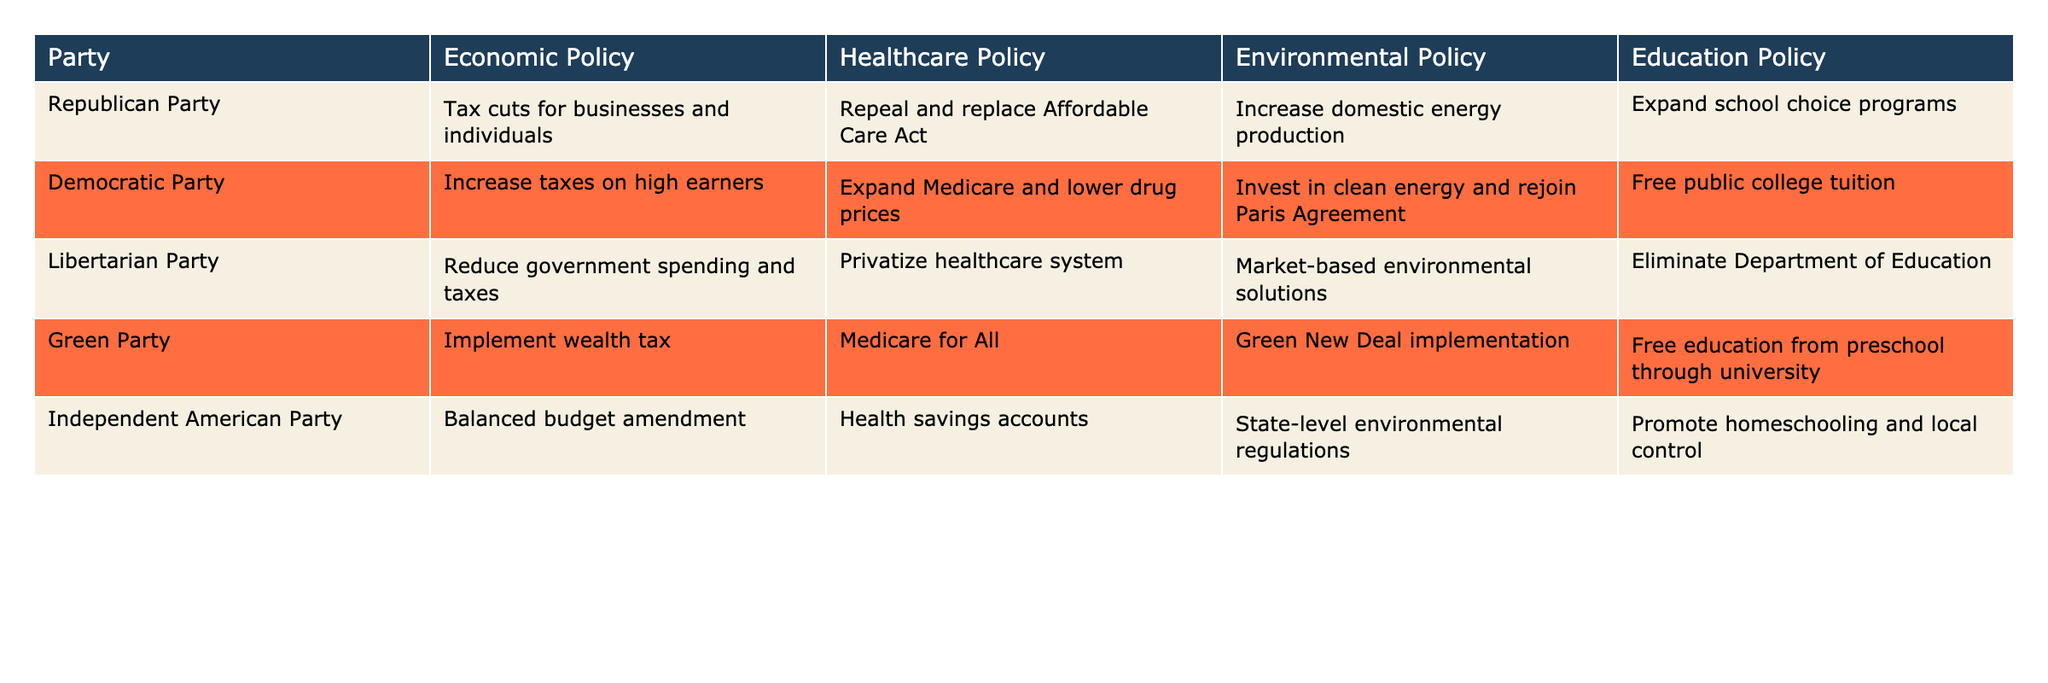What economic policy does the Green Party propose? The Green Party's economic policy is to implement a wealth tax. This information is directly found in the "Economic Policy" column of the Green Party row.
Answer: Implement wealth tax Which party proposes to expand Medicare and lower drug prices? The Democratic Party proposes to expand Medicare and lower drug prices, as indicated in the "Healthcare Policy" column for the Democratic Party row.
Answer: Democratic Party Do all parties support some form of educational reform? Yes, all parties propose changes in educational policy, whether it be expanding school choice, free college tuition, or promoting homeschooling. This can be confirmed by looking at the "Education Policy" column for each party.
Answer: Yes How many parties propose a balanced budget amendment? There is only one party, the Independent American Party, that proposes a balanced budget amendment based on the data in the table. This can be found in the "Economic Policy" column where the Independent American Party is listed.
Answer: One What environmental policies do the Democratic Party and the Green Party have in common? Both the Democratic Party and the Green Party emphasize clean energy and environmental reforms. The Democratic Party mentions investing in clean energy and rejoining the Paris Agreement, while the Green Party focuses on the implementation of the Green New Deal. This indicates a shared focus on environmental sustainability.
Answer: Clean energy initiatives Which party has the most radical healthcare proposal according to the table? The Green Party, which proposes Medicare for All, has the most radical healthcare proposal as it entails a complete overhaul of the current healthcare system as opposed to modifying existing frameworks. This can be verified from the "Healthcare Policy" column.
Answer: Green Party What is the average number of unique education policies proposed by the parties? To find the average number of unique education policies, count each unique policy listed in the "Education Policy" column (which are expand school choice, free college tuition, eliminate Department of Education, free education from preschool through university, and promote homeschooling) totaling 5 unique policies. Since there are 5 parties, the average is 5/5 = 1 policy per party.
Answer: 1 Which party proposes to privatize the healthcare system? The Libertarian Party proposes to privatize the healthcare system, which is stated in their "Healthcare Policy" row.
Answer: Libertarian Party Is it true that the Republican Party's healthcare policy includes expanding Medicare? No, it is false because the Republican Party's healthcare policy is to repeal and replace the Affordable Care Act, which does not include expanding Medicare. This is confirmed by checking the "Healthcare Policy" for the Republican Party, which does not mention Medicare expansion.
Answer: No 